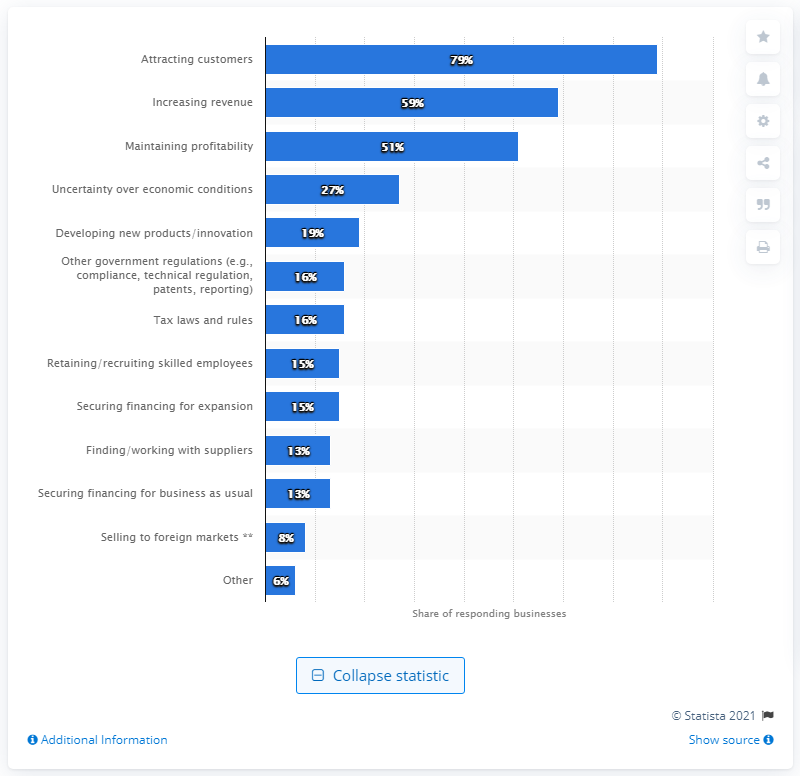Outline some significant characteristics in this image. In January 2018, 27% of SMEs reported that attracting new customers was their most significant challenge. In January 2018, 79% of SMEs reported that attracting new customers was their most significant challenge. 